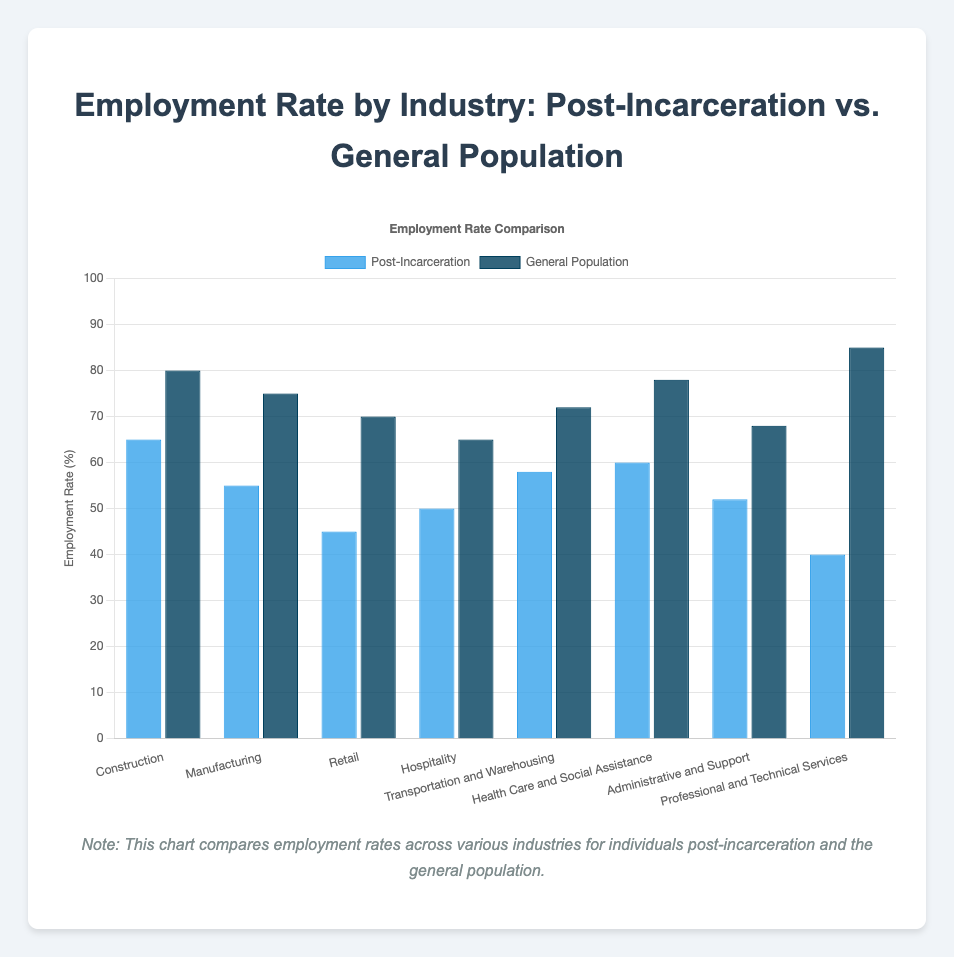Which industry has the highest employment rate for the general population? Look at the bar representing the general population's employment rate; the "Professional and Technical Services" bar is the tallest
Answer: Professional and Technical Services Which industry has the lowest employment rate for the post-incarceration group? Identify the shortest bar for the post-incarceration group; the "Professional and Technical Services" category has the shortest bar
Answer: Professional and Technical Services What is the difference in employment rates between post-incarceration and the general population for the Construction industry? Subtract the post-incarceration rate from the general population rate for Construction: 80 - 65
Answer: 15 Which industry shows the smallest gap in employment rates between the post-incarceration group and the general population? Find the industries with the smallest difference between bars. For Hospitality, the general population is at 65 and post-incarceration is at 50, a difference of 15, which is the smallest difference
Answer: Hospitality What's the combined employment rate of post-incarceration individuals in Manufacturing and Retail? Add the employment rates: Manufacturing (55) + Retail (45) = 100
Answer: 100 How much lower is the employment rate for post-incarceration individuals in Health Care and Social Assistance compared to the general population? Subtract the post-incarceration rate from the general population rate for Health Care and Social Assistance: 78 - 60
Answer: 18 Which industry has a higher employment rate for the post-incarceration group compared to Administrative and Support? Compare all post-incarceration rates with Administrative and Support (52). Construction (65), Manufacturing (55), Transportation and Warehousing (58), and Health Care and Social Assistance (60) are higher
Answer: Construction, Manufacturing, Transportation and Warehousing, Health Care and Social Assistance Are there any industries where the employment rate difference between post-incarceration and the general population is more than 30%? Subtract to find the differences: Professional and Technical Services (85 - 40 = 45, more than 30)
Answer: Yes, Professional and Technical Services What is the average employment rate for the general population across all industries displayed? Sum all employment rates for the general population (80 + 75 + 70 + 65 + 72 + 78 + 68 + 85 = 593), then divide by 8
Answer: 74.125 How does the employment rate of post-incarceration individuals in the Retail industry compare to the general population in the same industry? Retail employment rate for post-incarceration is 45, while for the general population it is 70, showing that post-incarceration is significantly lower
Answer: Much lower 